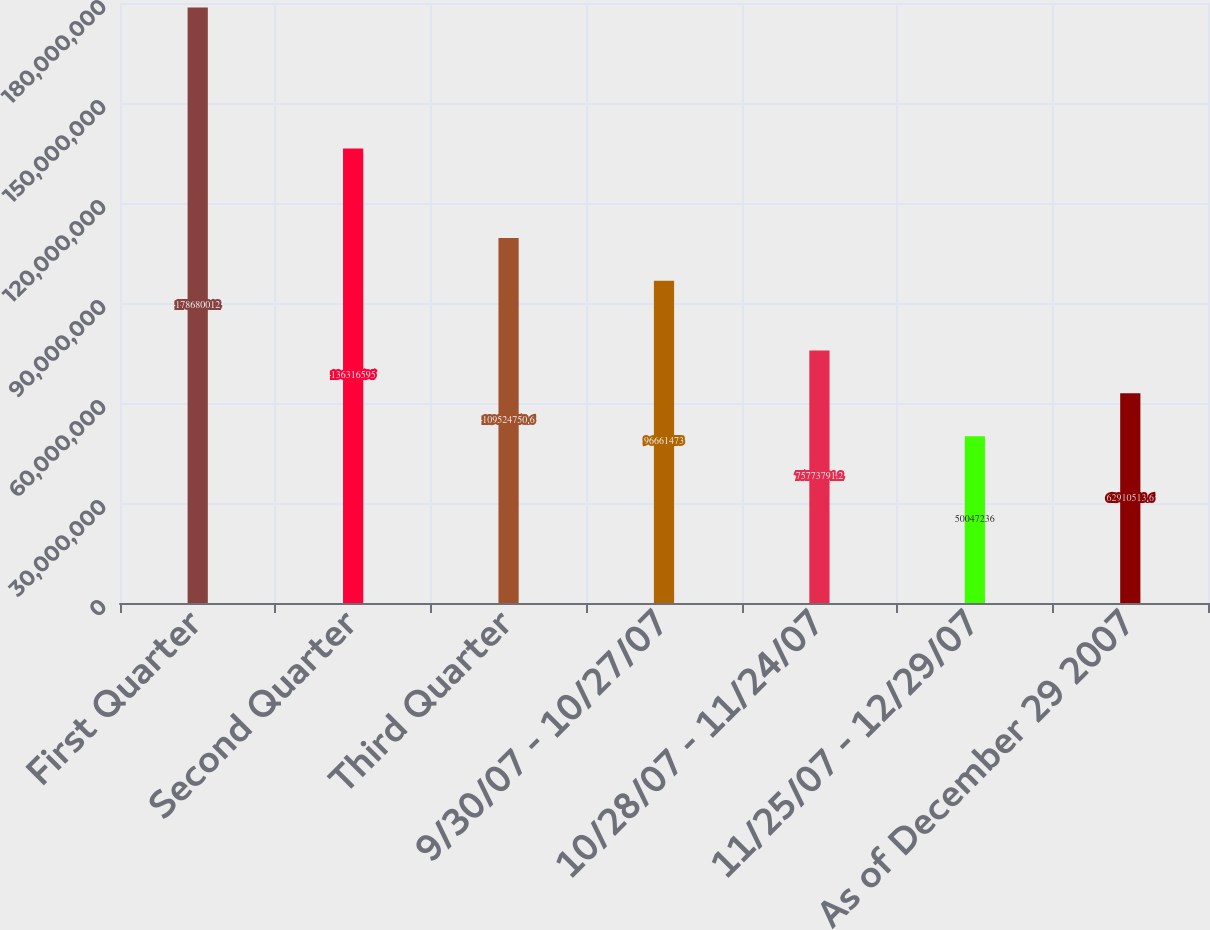Convert chart to OTSL. <chart><loc_0><loc_0><loc_500><loc_500><bar_chart><fcel>First Quarter<fcel>Second Quarter<fcel>Third Quarter<fcel>9/30/07 - 10/27/07<fcel>10/28/07 - 11/24/07<fcel>11/25/07 - 12/29/07<fcel>As of December 29 2007<nl><fcel>1.7868e+08<fcel>1.36317e+08<fcel>1.09525e+08<fcel>9.66615e+07<fcel>7.57738e+07<fcel>5.00472e+07<fcel>6.29105e+07<nl></chart> 